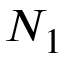<formula> <loc_0><loc_0><loc_500><loc_500>N _ { 1 }</formula> 